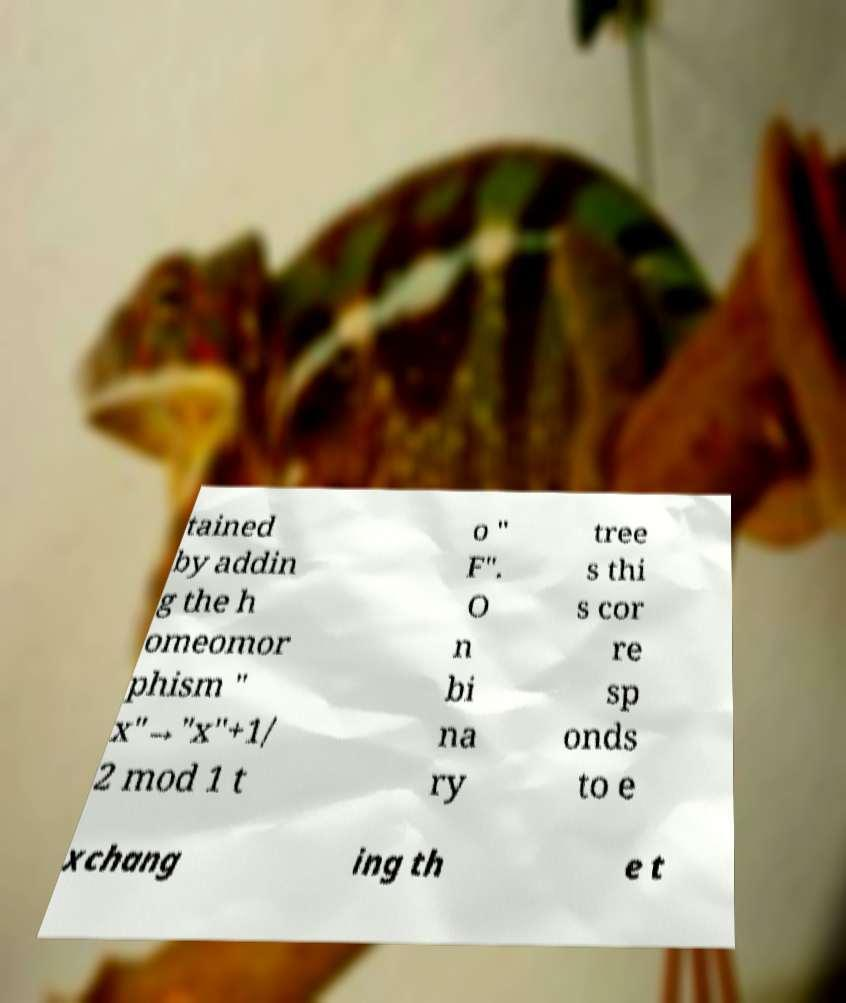For documentation purposes, I need the text within this image transcribed. Could you provide that? tained by addin g the h omeomor phism " x"→"x"+1/ 2 mod 1 t o " F". O n bi na ry tree s thi s cor re sp onds to e xchang ing th e t 